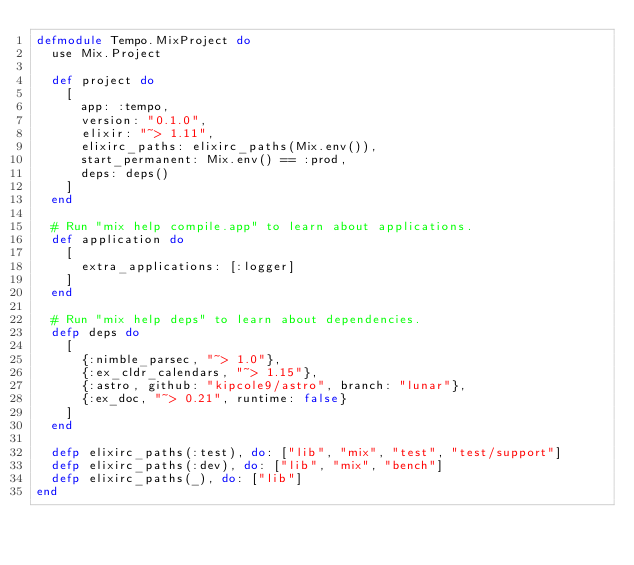<code> <loc_0><loc_0><loc_500><loc_500><_Elixir_>defmodule Tempo.MixProject do
  use Mix.Project

  def project do
    [
      app: :tempo,
      version: "0.1.0",
      elixir: "~> 1.11",
      elixirc_paths: elixirc_paths(Mix.env()),
      start_permanent: Mix.env() == :prod,
      deps: deps()
    ]
  end

  # Run "mix help compile.app" to learn about applications.
  def application do
    [
      extra_applications: [:logger]
    ]
  end

  # Run "mix help deps" to learn about dependencies.
  defp deps do
    [
      {:nimble_parsec, "~> 1.0"},
      {:ex_cldr_calendars, "~> 1.15"},
      {:astro, github: "kipcole9/astro", branch: "lunar"},
      {:ex_doc, "~> 0.21", runtime: false}
    ]
  end

  defp elixirc_paths(:test), do: ["lib", "mix", "test", "test/support"]
  defp elixirc_paths(:dev), do: ["lib", "mix", "bench"]
  defp elixirc_paths(_), do: ["lib"]
end
</code> 